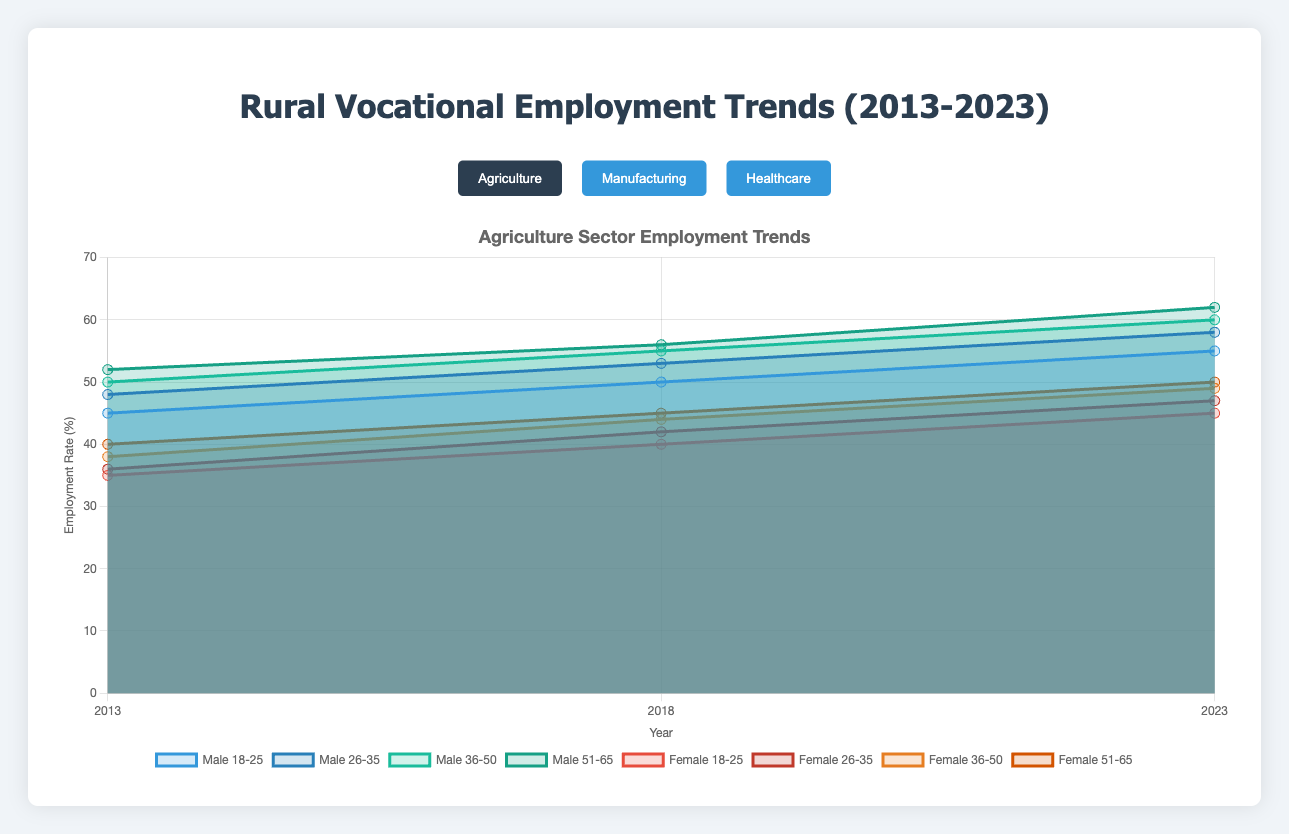What is the employment rate for males aged 18-25 in the healthcare sector in 2023? Look for the "Healthcare" sector, then locate the year 2023. Find the value corresponding to males in the 18-25 age group.
Answer: 45 How many age groups are being compared for employment trends in each sector? Count the number of age groups for which data is presented across males and females in each sector.
Answer: 4 Which sector shows a higher employment rate for females aged 26-35 in 2018, agriculture or manufacturing? Compare the employment rate for females aged 26-35 in 2018 between the agriculture and manufacturing sectors. Agriculture has 42%, while manufacturing has 32%.
Answer: Agriculture What's the difference in the employment rate of males aged 36-50 in the manufacturing sector between 2013 and 2023? Locate the employment rates for males aged 36-50 in the manufacturing sector for the years 2013 (34%) and 2023 (54%). Calculate the difference: 54% - 34% = 20%.
Answer: 20% In which year did the female employment rate in the healthcare sector for the 51-65 age group reach 50%? Check the female employment rate in the healthcare sector in different years for the 51-65 age group. In 2018, it is 50%.
Answer: 2018 What trend can you observe for the employment rate of males aged 26-35 in agriculture from 2013 to 2023? Observe the change in the employment rate of males aged 26-35 in the agriculture sector from 2013 (48%), 2018 (53%), to 2023 (58%). The trend shows a consistent increase.
Answer: Increasing Compare the employment rates of females aged 18-25 in the healthcare sector in 2013 and 2023. What is the percentage increase? Determine the employment rates in 2013 (35%) and 2023 (55%) for females aged 18-25 in the healthcare sector. Calculate the percentage increase: [(55-35)/35]*100 = 57.14%.
Answer: 57.14% Which gender and age group in the healthcare sector shows the highest employment rate in 2023? Check all employment rates for males and females in different age groups in the healthcare sector in 2023. Females aged 51-65 have the highest rate at 60%.
Answer: Females aged 51-65 In the manufacturing sector, what was the employment trend for males aged 51-65 from 2013 to 2023? Analyze the employment rates for males aged 51-65 in the manufacturing sector in 2013 (35%), 2018 (45%), and 2023 (55%). The trend shows a steady increase.
Answer: Increasing Identify which sector has the most significant gender disparity in employment rates for the 18-25 age group in 2023. Compare the differences between male and female employment rates for the 18-25 age group in 2023 across all sectors. Agriculture has the largest disparity: Male (55%), Female (45%), with a difference of 10%.
Answer: Agriculture 